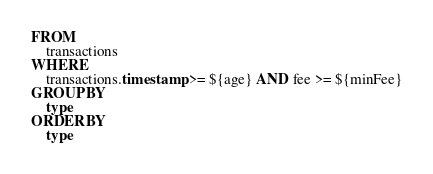Convert code to text. <code><loc_0><loc_0><loc_500><loc_500><_SQL_>FROM 
    transactions 
WHERE 
    transactions.timestamp >= ${age} AND fee >= ${minFee}
GROUP BY
    type
ORDER BY
    type</code> 